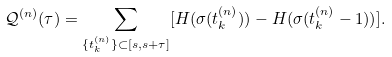Convert formula to latex. <formula><loc_0><loc_0><loc_500><loc_500>\mathcal { Q } ^ { ( n ) } ( \tau ) = \sum _ { \{ t ^ { ( n ) } _ { k } \} \subset [ s , s + \tau ] } [ H ( \sigma ( t ^ { ( n ) } _ { k } ) ) - H ( \sigma ( t ^ { ( n ) } _ { k } - 1 ) ) ] .</formula> 